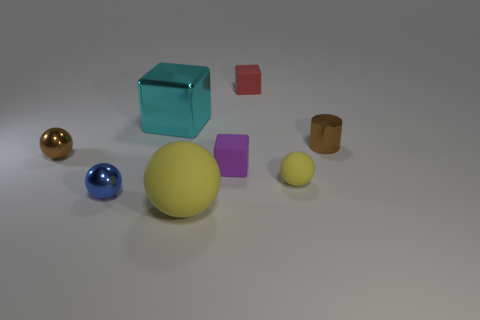Subtract all red rubber blocks. How many blocks are left? 2 Add 1 tiny blue cylinders. How many objects exist? 9 Subtract all purple blocks. How many blocks are left? 2 Subtract all brown cubes. How many yellow spheres are left? 2 Subtract all cylinders. How many objects are left? 7 Add 4 large rubber balls. How many large rubber balls are left? 5 Add 8 tiny red metallic spheres. How many tiny red metallic spheres exist? 8 Subtract 2 yellow balls. How many objects are left? 6 Subtract 4 spheres. How many spheres are left? 0 Subtract all purple balls. Subtract all cyan cylinders. How many balls are left? 4 